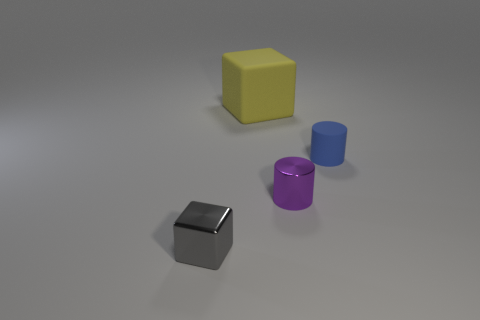Add 4 yellow things. How many objects exist? 8 Subtract all purple cubes. Subtract all cyan spheres. How many cubes are left? 2 Subtract 0 purple spheres. How many objects are left? 4 Subtract all blue things. Subtract all red metallic spheres. How many objects are left? 3 Add 3 tiny gray objects. How many tiny gray objects are left? 4 Add 4 big cyan metal cubes. How many big cyan metal cubes exist? 4 